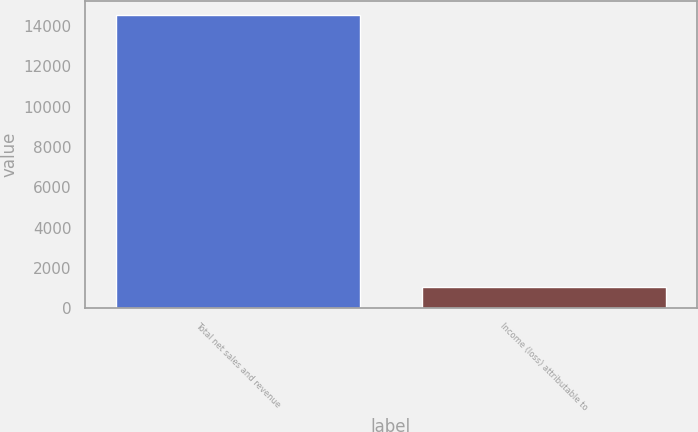Convert chart to OTSL. <chart><loc_0><loc_0><loc_500><loc_500><bar_chart><fcel>Total net sales and revenue<fcel>Income (loss) attributable to<nl><fcel>14522<fcel>1076<nl></chart> 